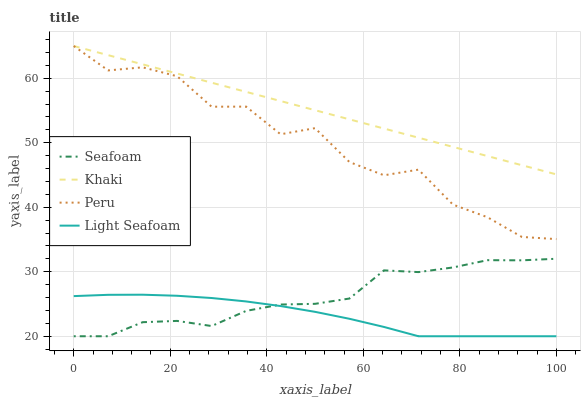Does Light Seafoam have the minimum area under the curve?
Answer yes or no. Yes. Does Khaki have the maximum area under the curve?
Answer yes or no. Yes. Does Seafoam have the minimum area under the curve?
Answer yes or no. No. Does Seafoam have the maximum area under the curve?
Answer yes or no. No. Is Khaki the smoothest?
Answer yes or no. Yes. Is Peru the roughest?
Answer yes or no. Yes. Is Seafoam the smoothest?
Answer yes or no. No. Is Seafoam the roughest?
Answer yes or no. No. Does Light Seafoam have the lowest value?
Answer yes or no. Yes. Does Khaki have the lowest value?
Answer yes or no. No. Does Peru have the highest value?
Answer yes or no. Yes. Does Seafoam have the highest value?
Answer yes or no. No. Is Seafoam less than Peru?
Answer yes or no. Yes. Is Khaki greater than Light Seafoam?
Answer yes or no. Yes. Does Light Seafoam intersect Seafoam?
Answer yes or no. Yes. Is Light Seafoam less than Seafoam?
Answer yes or no. No. Is Light Seafoam greater than Seafoam?
Answer yes or no. No. Does Seafoam intersect Peru?
Answer yes or no. No. 